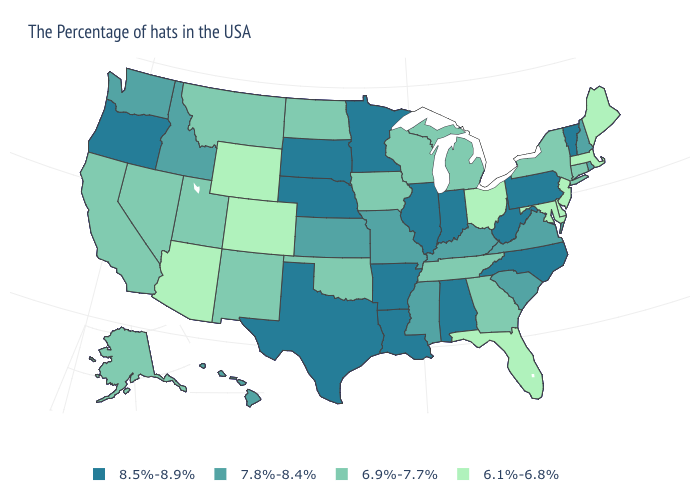How many symbols are there in the legend?
Concise answer only. 4. Is the legend a continuous bar?
Be succinct. No. Does Colorado have the highest value in the West?
Write a very short answer. No. What is the lowest value in the West?
Write a very short answer. 6.1%-6.8%. Which states have the lowest value in the USA?
Short answer required. Maine, Massachusetts, New Jersey, Delaware, Maryland, Ohio, Florida, Wyoming, Colorado, Arizona. What is the value of Wyoming?
Keep it brief. 6.1%-6.8%. What is the lowest value in the South?
Quick response, please. 6.1%-6.8%. Which states have the lowest value in the West?
Short answer required. Wyoming, Colorado, Arizona. What is the value of Georgia?
Be succinct. 6.9%-7.7%. Name the states that have a value in the range 6.9%-7.7%?
Concise answer only. Connecticut, New York, Georgia, Michigan, Tennessee, Wisconsin, Iowa, Oklahoma, North Dakota, New Mexico, Utah, Montana, Nevada, California, Alaska. Does Georgia have the highest value in the USA?
Quick response, please. No. Among the states that border Iowa , which have the highest value?
Answer briefly. Illinois, Minnesota, Nebraska, South Dakota. Does the first symbol in the legend represent the smallest category?
Short answer required. No. Name the states that have a value in the range 6.1%-6.8%?
Answer briefly. Maine, Massachusetts, New Jersey, Delaware, Maryland, Ohio, Florida, Wyoming, Colorado, Arizona. Name the states that have a value in the range 8.5%-8.9%?
Quick response, please. Vermont, Pennsylvania, North Carolina, West Virginia, Indiana, Alabama, Illinois, Louisiana, Arkansas, Minnesota, Nebraska, Texas, South Dakota, Oregon. 